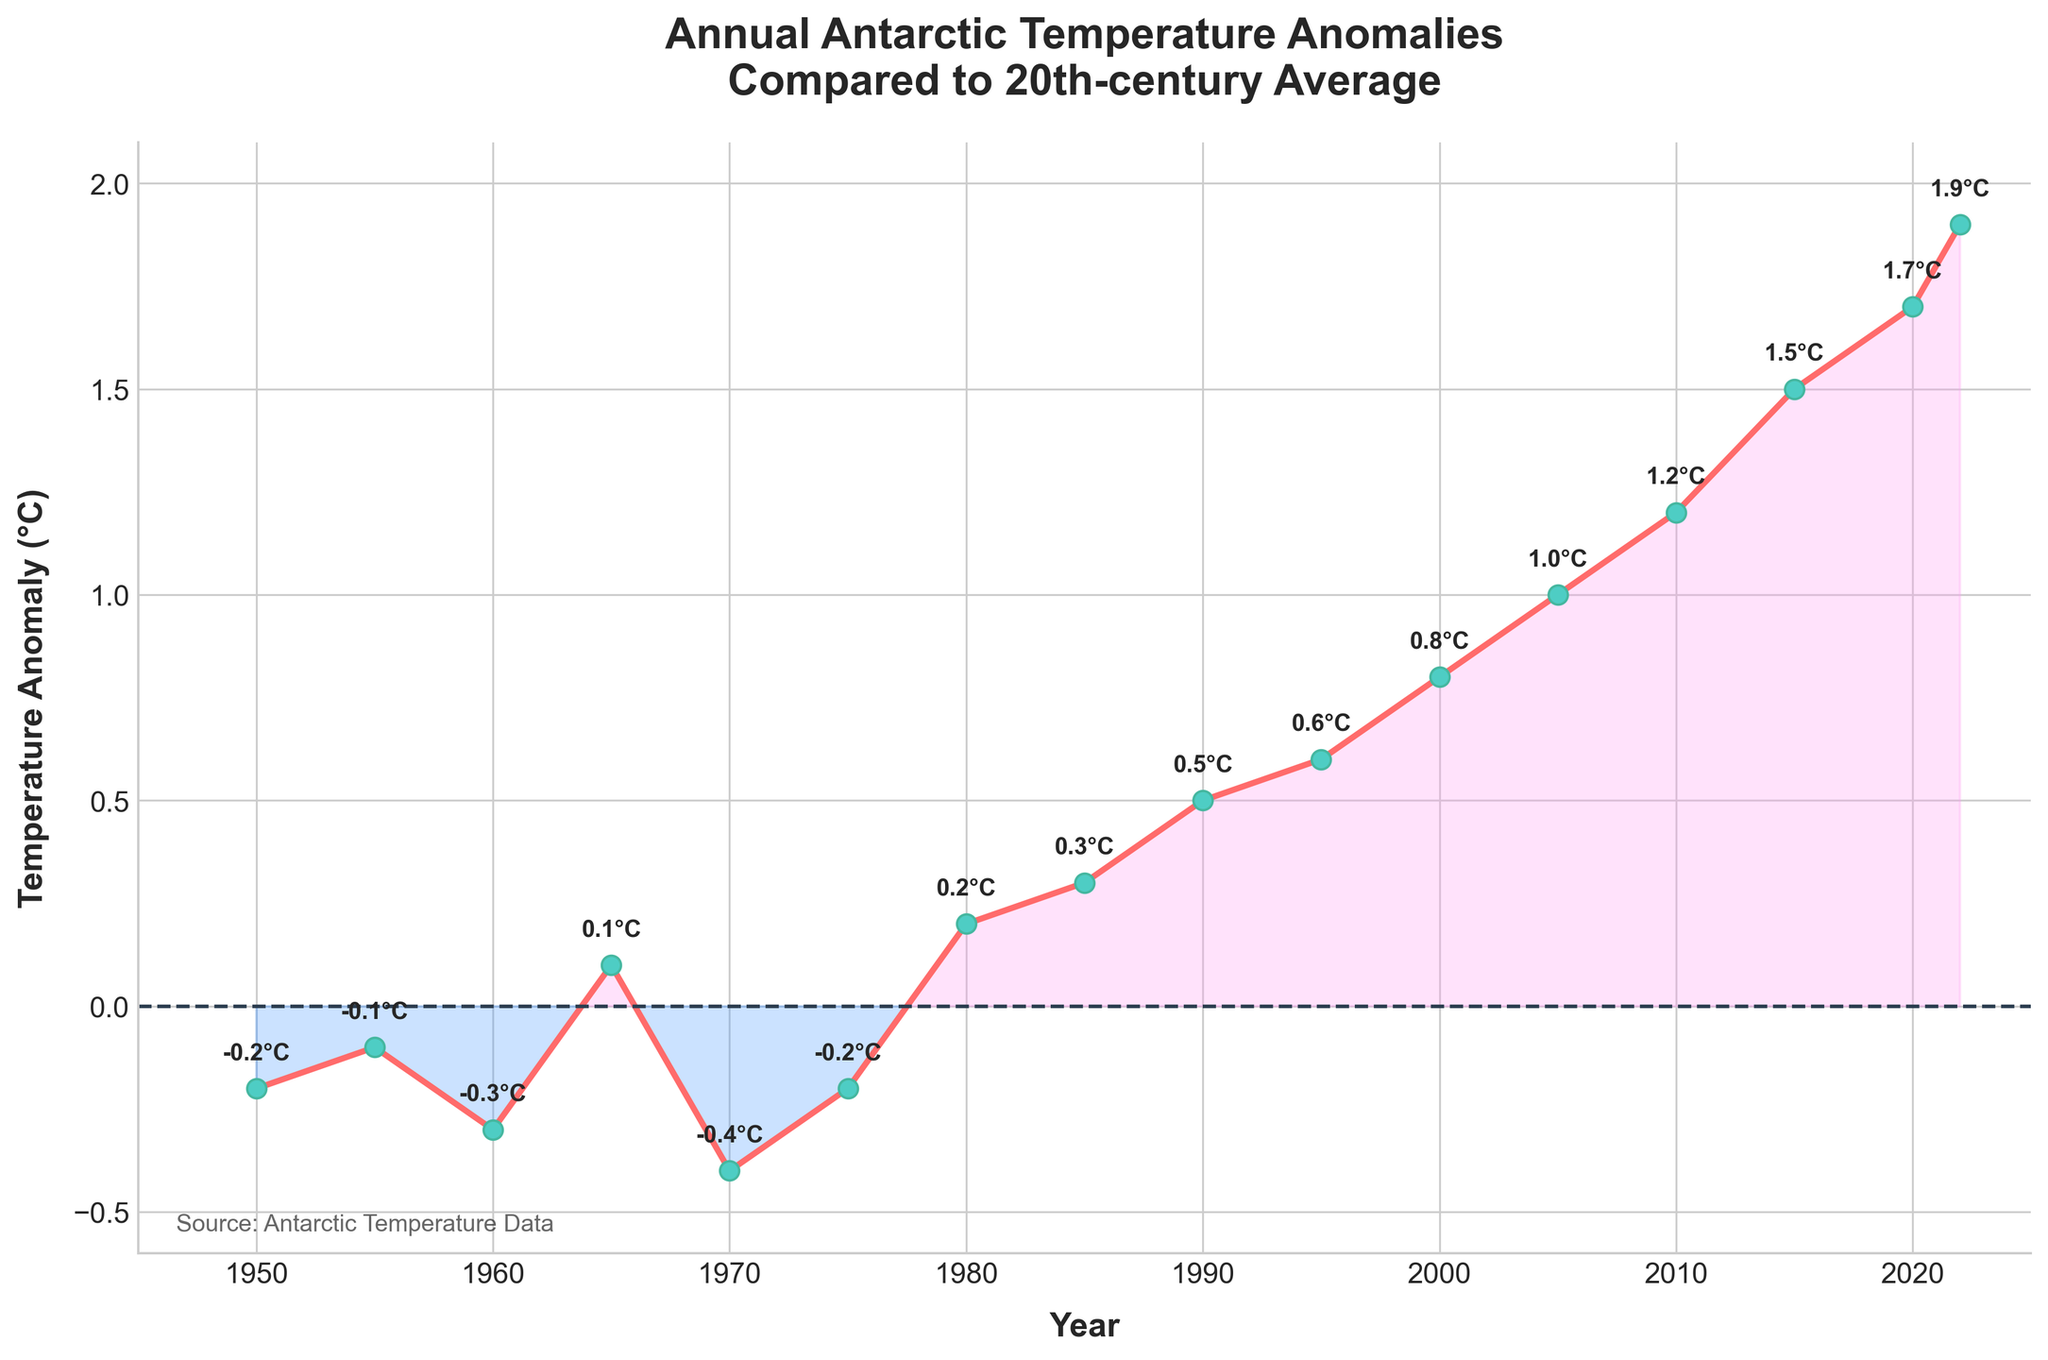What is the trend of the temperature anomalies from 1950 to 2022? To understand the trend, observe the overall direction of the temperature anomalies from the start to the end. The anomalies generally increase from around -0.2°C in 1950 to 1.9°C in 2022, indicating a warming trend.
Answer: Warming trend How much did the temperature anomaly increase between 1980 and 2022? The temperature anomaly in 1980 was 0.2°C and in 2022 it was 1.9°C. The increase is calculated as 1.9°C - 0.2°C = 1.7°C.
Answer: 1.7°C Which year shows the highest temperature anomaly? By looking at the highest point on the line chart, 2022 exhibits the peak temperature anomaly at 1.9°C.
Answer: 2022 Which years had negative temperature anomalies? Negative anomalies are below the 0°C line. These years include 1950, 1955, 1960, 1970, and 1975.
Answer: 1950, 1955, 1960, 1970, 1975 What was the temperature anomaly in 2010? Locate the data point corresponding to the year 2010 on the line chart, which shows a temperature anomaly of 1.2°C.
Answer: 1.2°C Compare the temperature anomaly in 1965 with 1990. Which one is higher? The temperature anomaly in 1965 was 0.1°C and in 1990 it was 0.5°C. Therefore, the 1990 anomaly is higher.
Answer: 1990 Calculate the average temperature anomaly for the years 2000, 2005, and 2010. The anomalies are 0.8°C (2000), 1.0°C (2005), and 1.2°C (2010). Their sum is 3.0°C, and the average is 3.0°C / 3 = 1.0°C.
Answer: 1.0°C Which color is used to fill the area under the curve where temperature anomalies are positive? Positive temperature anomalies are filled with a purplish/pink color under the curve.
Answer: Purplish/pink What is the difference in temperature anomaly between 1990 and 2015? The anomaly in 1990 was 0.5°C and in 2015 it was 1.5°C. The difference is 1.5°C - 0.5°C = 1.0°C.
Answer: 1.0°C 